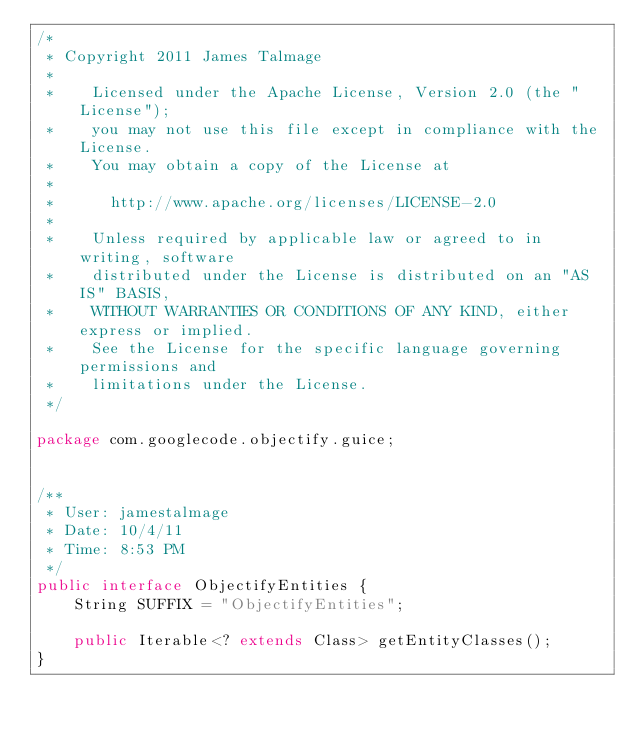Convert code to text. <code><loc_0><loc_0><loc_500><loc_500><_Java_>/*
 * Copyright 2011 James Talmage
 *
 *    Licensed under the Apache License, Version 2.0 (the "License");
 *    you may not use this file except in compliance with the License.
 *    You may obtain a copy of the License at
 *
 *      http://www.apache.org/licenses/LICENSE-2.0
 *
 *    Unless required by applicable law or agreed to in writing, software
 *    distributed under the License is distributed on an "AS IS" BASIS,
 *    WITHOUT WARRANTIES OR CONDITIONS OF ANY KIND, either express or implied.
 *    See the License for the specific language governing permissions and
 *    limitations under the License.
 */

package com.googlecode.objectify.guice;


/**
 * User: jamestalmage
 * Date: 10/4/11
 * Time: 8:53 PM
 */
public interface ObjectifyEntities {
    String SUFFIX = "ObjectifyEntities";

    public Iterable<? extends Class> getEntityClasses();
}
</code> 